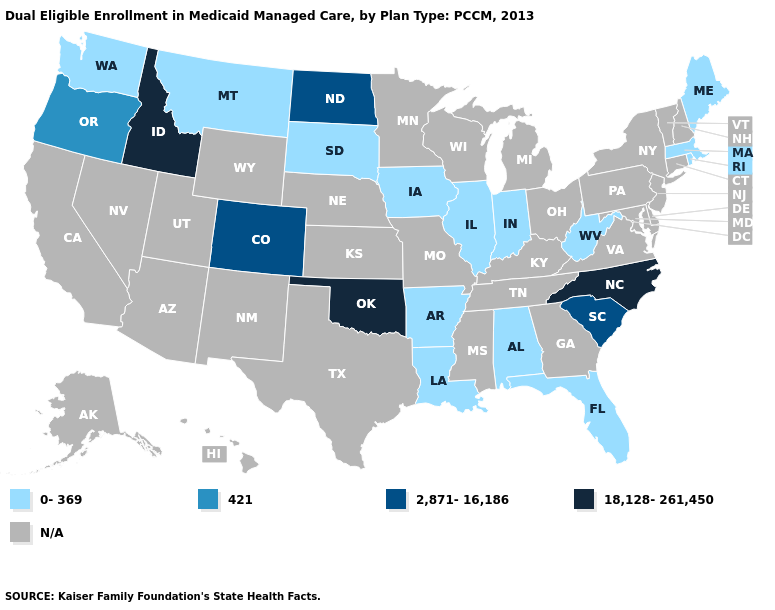Name the states that have a value in the range 2,871-16,186?
Keep it brief. Colorado, North Dakota, South Carolina. Which states have the lowest value in the USA?
Be succinct. Alabama, Arkansas, Florida, Illinois, Indiana, Iowa, Louisiana, Maine, Massachusetts, Montana, Rhode Island, South Dakota, Washington, West Virginia. Among the states that border Texas , which have the lowest value?
Give a very brief answer. Arkansas, Louisiana. What is the lowest value in states that border Virginia?
Quick response, please. 0-369. What is the lowest value in states that border Wyoming?
Concise answer only. 0-369. Name the states that have a value in the range 0-369?
Write a very short answer. Alabama, Arkansas, Florida, Illinois, Indiana, Iowa, Louisiana, Maine, Massachusetts, Montana, Rhode Island, South Dakota, Washington, West Virginia. Name the states that have a value in the range 421?
Concise answer only. Oregon. What is the value of Tennessee?
Concise answer only. N/A. Name the states that have a value in the range 2,871-16,186?
Quick response, please. Colorado, North Dakota, South Carolina. What is the value of Colorado?
Keep it brief. 2,871-16,186. What is the highest value in states that border Illinois?
Give a very brief answer. 0-369. What is the highest value in states that border Kansas?
Answer briefly. 18,128-261,450. Name the states that have a value in the range 2,871-16,186?
Concise answer only. Colorado, North Dakota, South Carolina. Name the states that have a value in the range 0-369?
Keep it brief. Alabama, Arkansas, Florida, Illinois, Indiana, Iowa, Louisiana, Maine, Massachusetts, Montana, Rhode Island, South Dakota, Washington, West Virginia. 